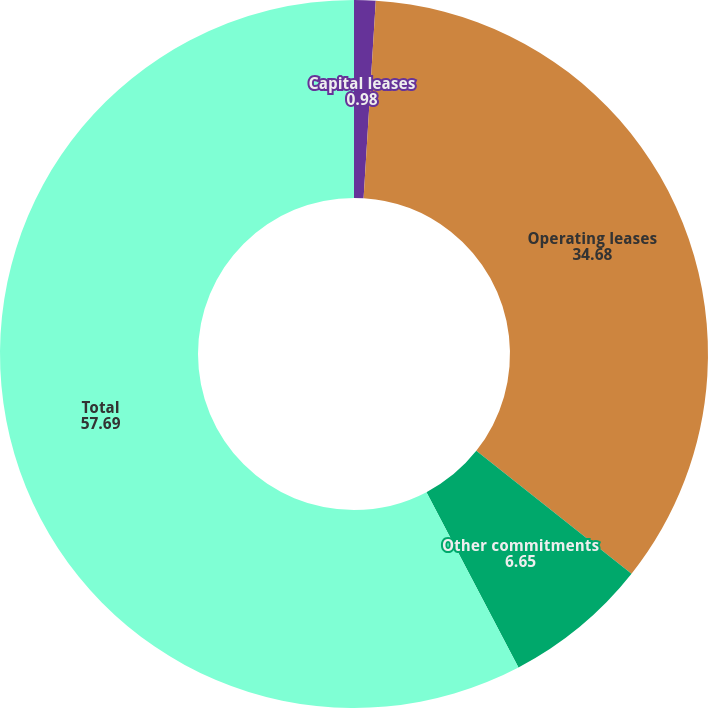Convert chart to OTSL. <chart><loc_0><loc_0><loc_500><loc_500><pie_chart><fcel>Capital leases<fcel>Operating leases<fcel>Other commitments<fcel>Total<nl><fcel>0.98%<fcel>34.68%<fcel>6.65%<fcel>57.69%<nl></chart> 